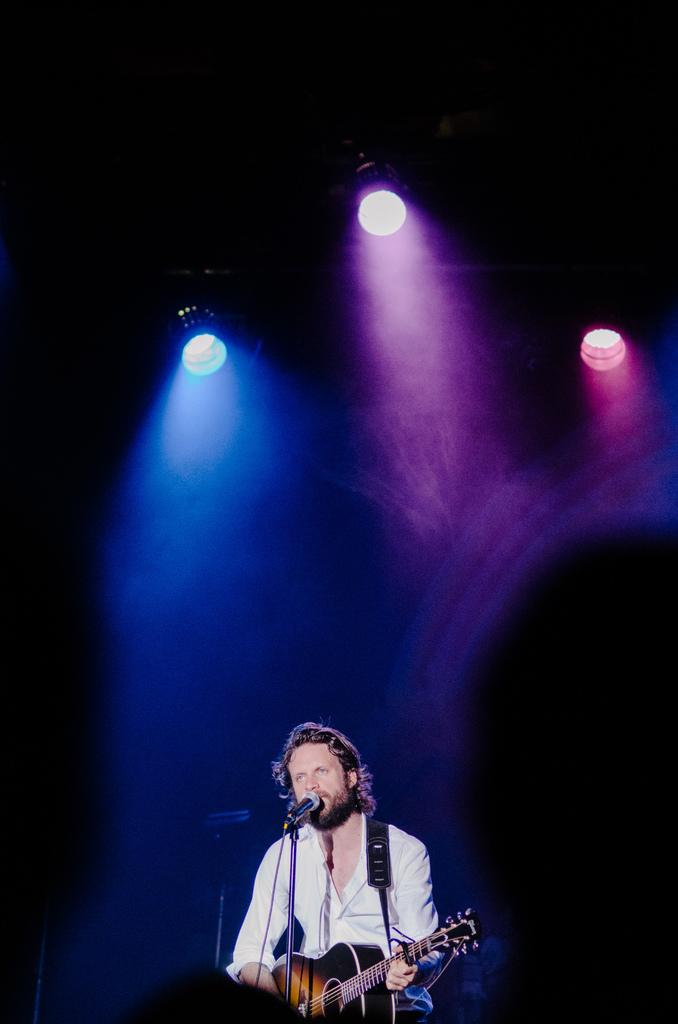What is the man in the image doing? The man is sitting and singing a song. What instrument is the man holding in the image? The man is holding a guitar with his left hand. How is the man playing the guitar? The man is playing the guitar with his right hand. What type of lighting is present in the image? There are disco lights present. How many brothers does the man have in the image? There is no information about the man's brothers in the image. What is the man's temper like while playing the guitar? There is no information about the man's temper in the image. 